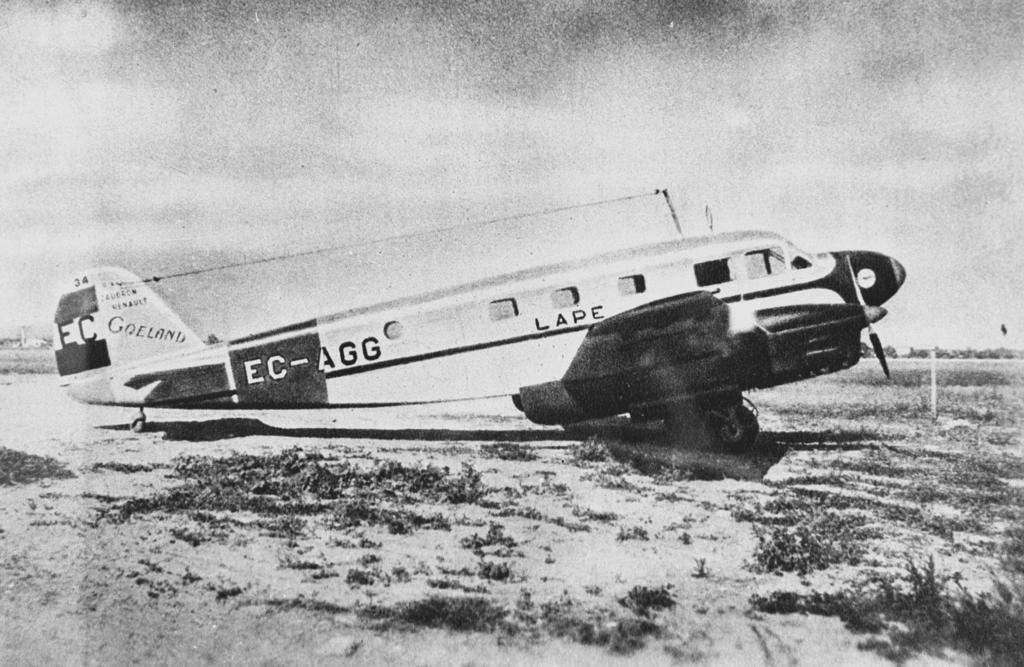What type of plane is this?
Give a very brief answer. Lape. What are the letters on the tail section of the plane?
Your answer should be compact. Ec. 